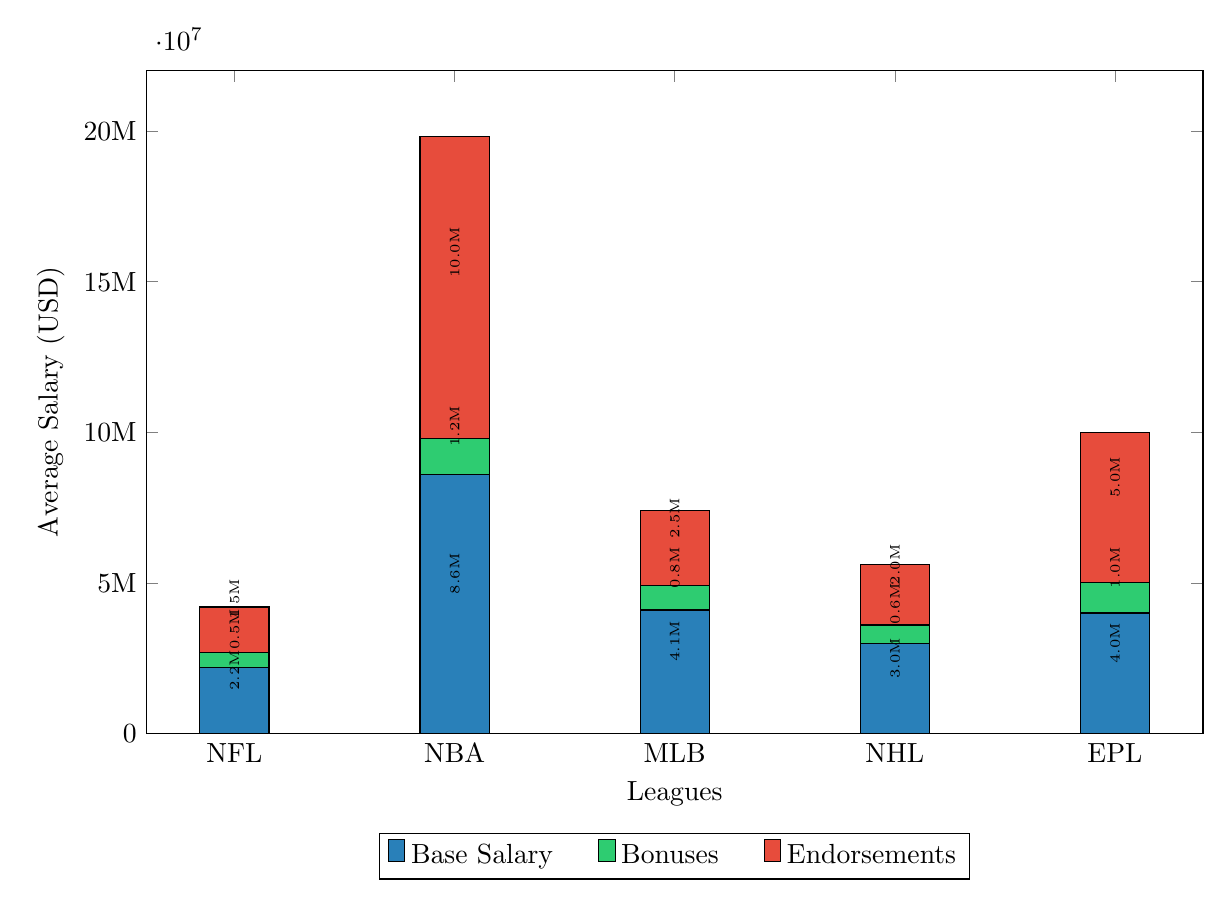What is the average base salary for athletes in the NBA? The NBA's average base salary is represented on the stacked column chart with the first color (base salary), showing a value of 8.6 million USD.
Answer: 8.6M Which league has the highest average salary in endorsements? The endorsement section of the chart shows the highest value, which is 10 million USD for the NBA.
Answer: 10M How much is the total average salary for NHL athletes? To determine the total average salary for the NHL, add the values for base salary (3 million), bonuses (0.6 million), and endorsements (2 million), resulting in a total of 5.6 million USD.
Answer: 5.6M What is the average bonus for athletes in the EPL? The EPL's bonus amount is illustrated with a value of 1 million USD in the bonus section of the stacked column chart.
Answer: 1M Which league has the lowest average total salary? The league with the lowest total is the NHL, with a combination of values adding up to 5.6 million USD when all three salary components are considered.
Answer: NHL How does the average base salary for NFL compare to EPL? The NFL has a base salary of 2.2 million USD, while the EPL has a base salary of 4 million USD. Thus, the EPL has a higher base salary by 1.8 million USD.
Answer: Higher What is the combined total of bonuses and endorsements for MLB athletes? For MLB, the bonuses are 0.8 million and endorsements are 2.5 million, totaling these gives 3.3 million USD.
Answer: 3.3M What percentage of the NBA’s total average salary comes from endorsements? The total for the NBA averages 19.8 million, with endorsements at 10 million; thus, the percentage of endorsement contributions is (10/19.8)*100, which is approximately 50.5%.
Answer: 50.5% Which league has the second-highest average base salary? By observing the base salary values presented, the NHL's base salary at 3 million gives them the second-highest average base salary after the NBA.
Answer: NHL 